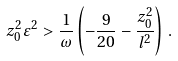<formula> <loc_0><loc_0><loc_500><loc_500>z _ { 0 } ^ { 2 } \varepsilon ^ { 2 } > { \frac { 1 } { \omega } } \left ( - { \frac { 9 } { 2 0 } } - { \frac { z _ { 0 } ^ { 2 } } { l ^ { 2 } } } \right ) \, .</formula> 